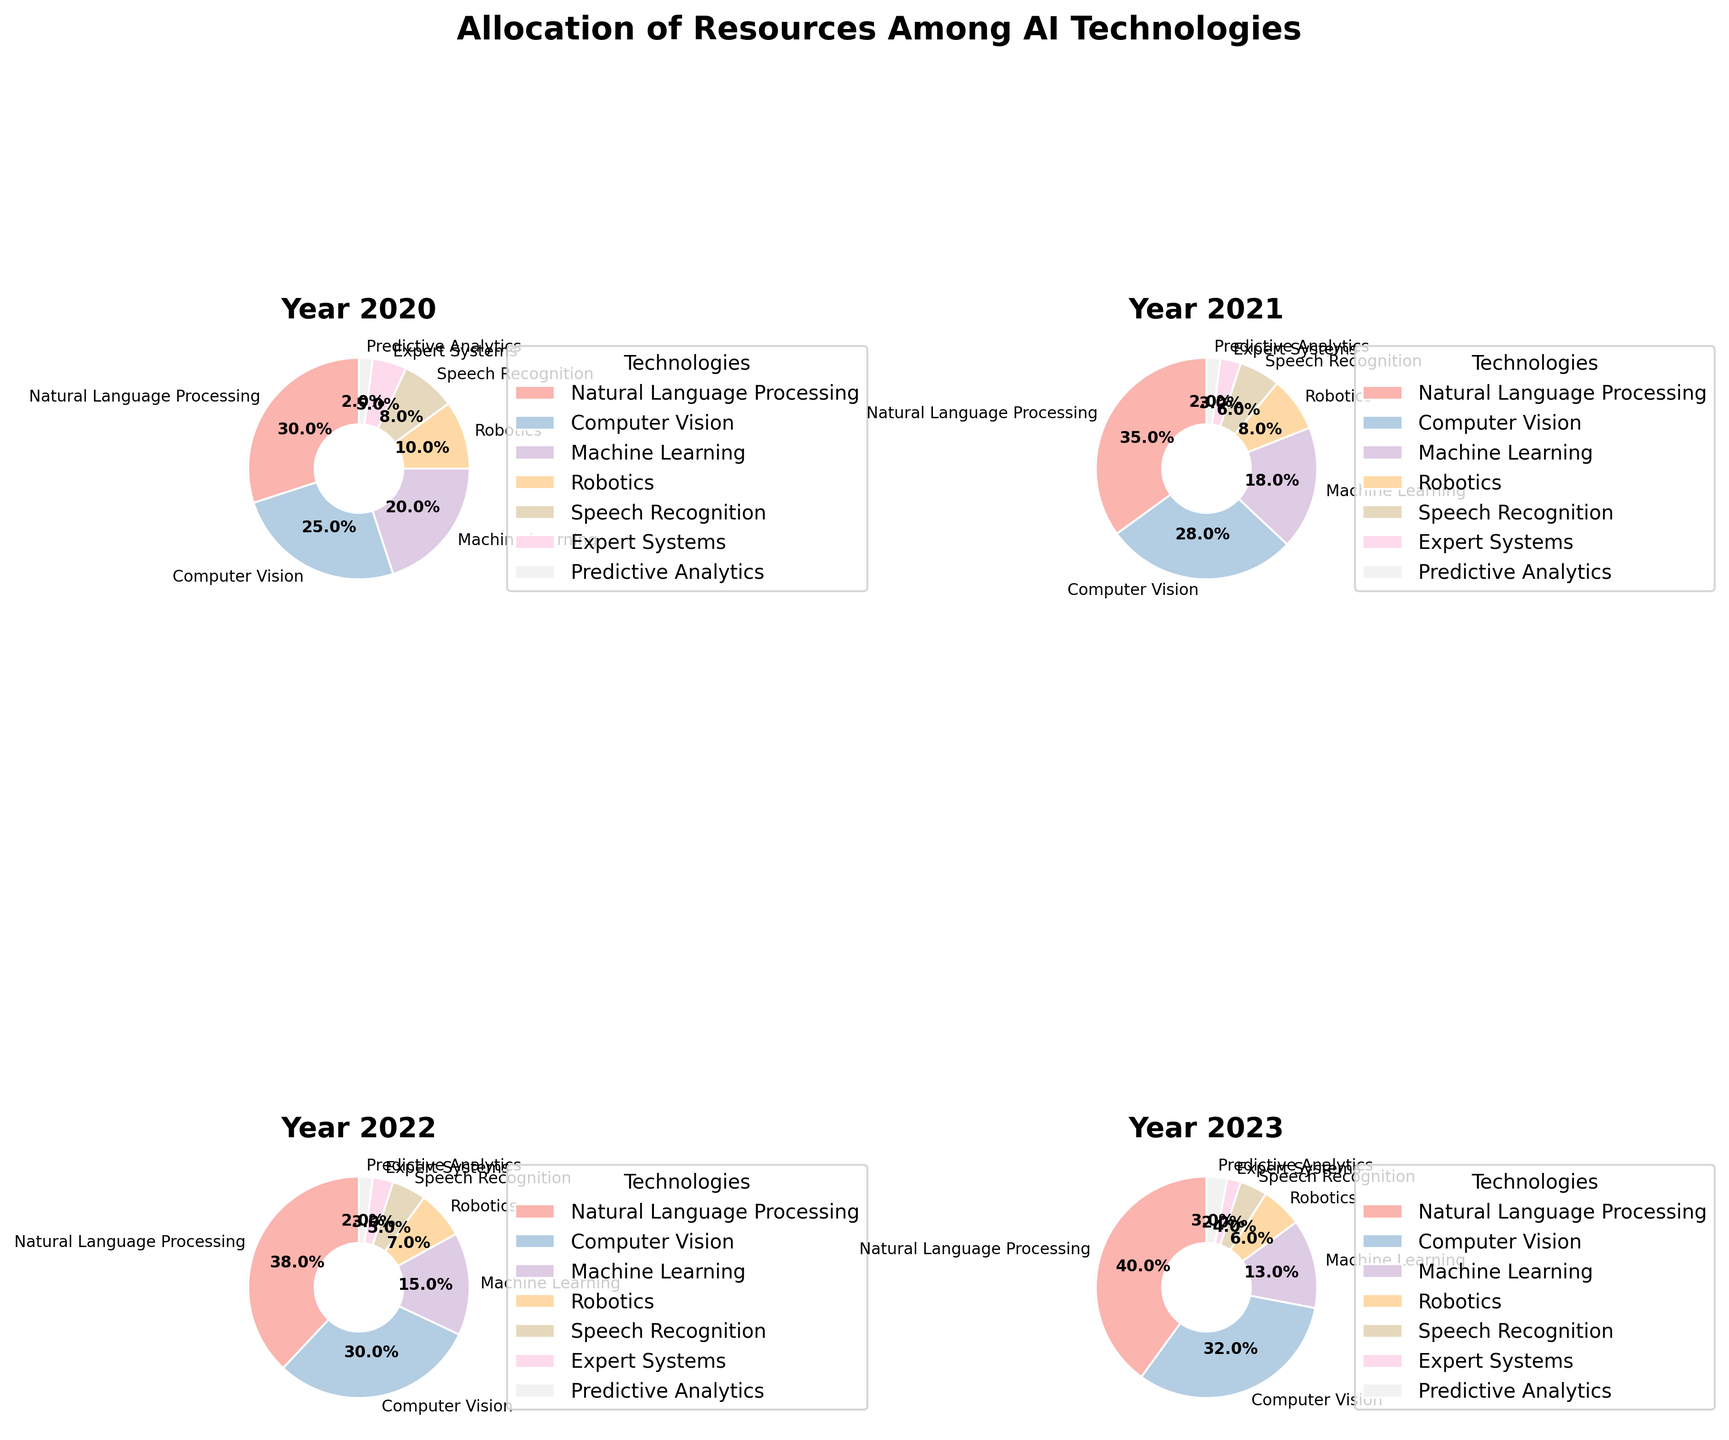Which technology has the largest share in 2023? Looking at the pie chart for 2023, the sector with the largest share is the one labeled "Natural Language Processing".
Answer: Natural Language Processing How did the allocation for Robotics change from 2020 to 2023? Comparing the 2020 pie chart to the 2023 pie chart, we see that Robotics decreased from 10% in 2020 to 6% in 2023.
Answer: Decreased by 4% Which year had the lowest allocation for Expert Systems? By checking the pie charts for all four years, we see that 2023 had the lowest allocation of 2% for Expert Systems.
Answer: 2023 What is the difference in the share of Computer Vision technology between 2020 and 2023? In 2020, the share for Computer Vision was 25% and in 2023, it was 32%. The difference is 32% - 25% = 7%.
Answer: 7% Which two technologies together accounted for the majority of the allocation in 2021? In the 2021 pie chart, Natural Language Processing (35%) and Computer Vision (28%) together accounted for 35% + 28% = 63%, which is more than half.
Answer: Natural Language Processing and Computer Vision How does the share of Predictive Analytics in 2023 compare to that in 2020? In 2020, Predictive Analytics had a share of 2%, while in 2023, it increased slightly to 3%.
Answer: Increased by 1% Which year saw the largest allocation for Speech Recognition? From the pie charts, the largest allocation for Speech Recognition is in 2020 at 8%.
Answer: 2020 Between 2021 and 2023, which technology saw the largest decrease in its share? By comparing the pie charts for 2021 and 2023, Machine Learning saw the largest decrease, from 18% in 2021 to 13% in 2023, which is a decrease of 5%.
Answer: Machine Learning 